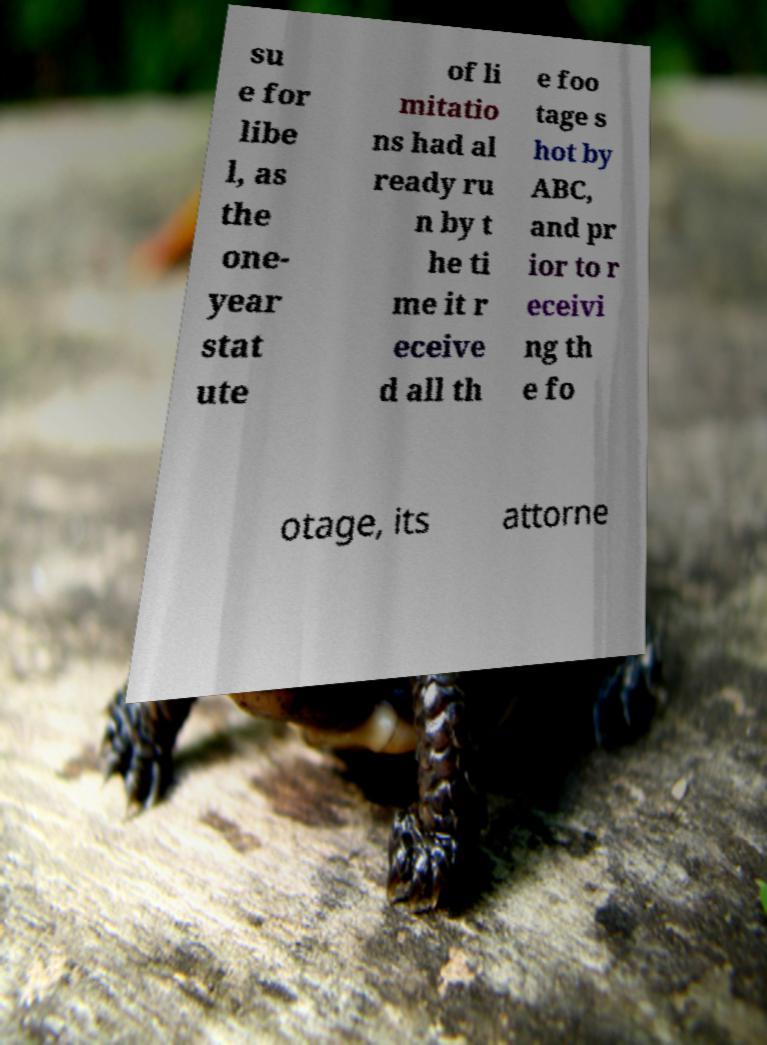There's text embedded in this image that I need extracted. Can you transcribe it verbatim? su e for libe l, as the one- year stat ute of li mitatio ns had al ready ru n by t he ti me it r eceive d all th e foo tage s hot by ABC, and pr ior to r eceivi ng th e fo otage, its attorne 